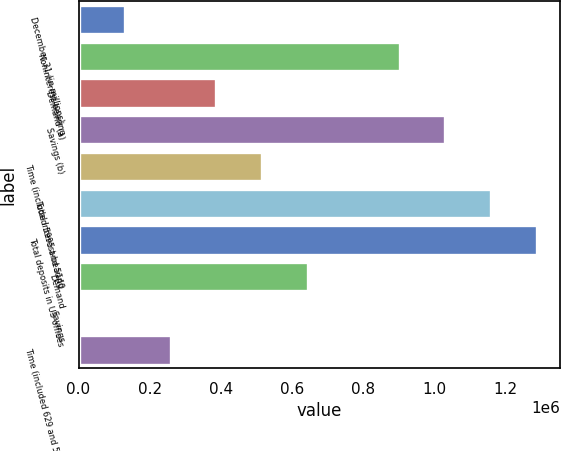<chart> <loc_0><loc_0><loc_500><loc_500><bar_chart><fcel>December 31 (in millions)<fcel>Noninterest-bearing<fcel>Demand (a)<fcel>Savings (b)<fcel>Time (included 5995 and 5140<fcel>Total interest-bearing<fcel>Total deposits in US offices<fcel>Demand<fcel>Savings<fcel>Time (included 629 and 593 at<nl><fcel>129751<fcel>901760<fcel>387088<fcel>1.03043e+06<fcel>515756<fcel>1.1591e+06<fcel>1.28776e+06<fcel>644424<fcel>1083<fcel>258419<nl></chart> 